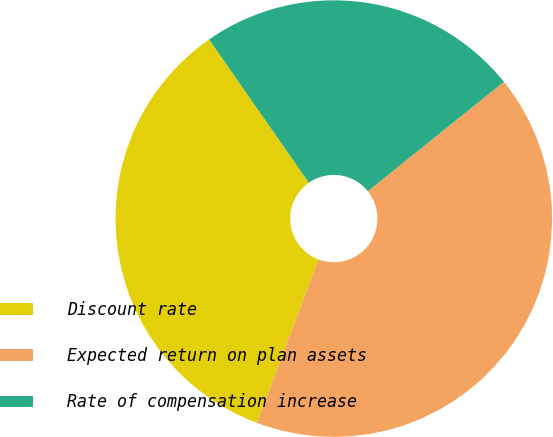Convert chart to OTSL. <chart><loc_0><loc_0><loc_500><loc_500><pie_chart><fcel>Discount rate<fcel>Expected return on plan assets<fcel>Rate of compensation increase<nl><fcel>34.59%<fcel>41.51%<fcel>23.9%<nl></chart> 